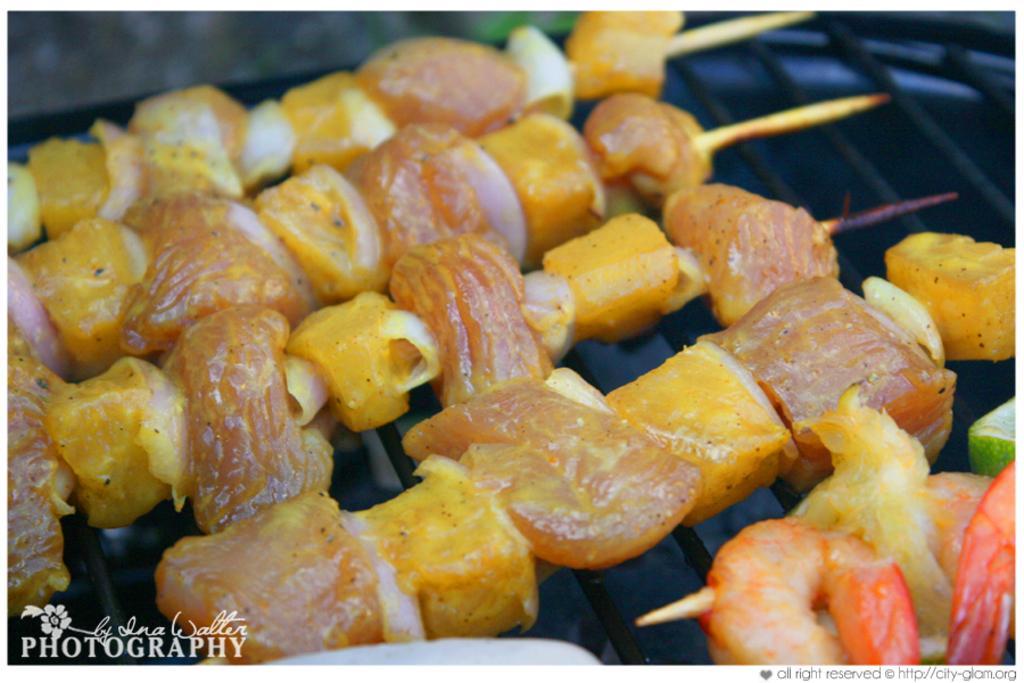Could you give a brief overview of what you see in this image? In this image I can see a logo, meat and seafood items on a grill. This image is taken may be in a restaurant. 